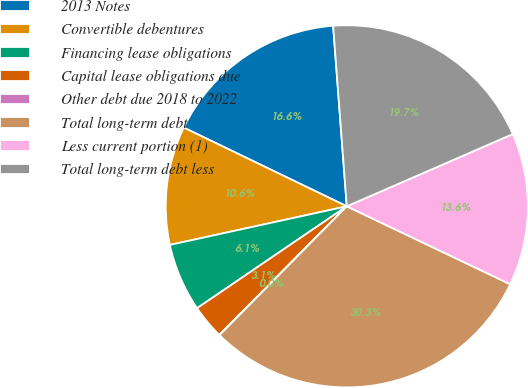<chart> <loc_0><loc_0><loc_500><loc_500><pie_chart><fcel>2013 Notes<fcel>Convertible debentures<fcel>Financing lease obligations<fcel>Capital lease obligations due<fcel>Other debt due 2018 to 2022<fcel>Total long-term debt<fcel>Less current portion (1)<fcel>Total long-term debt less<nl><fcel>16.64%<fcel>10.58%<fcel>6.09%<fcel>3.06%<fcel>0.03%<fcel>30.32%<fcel>13.61%<fcel>19.67%<nl></chart> 